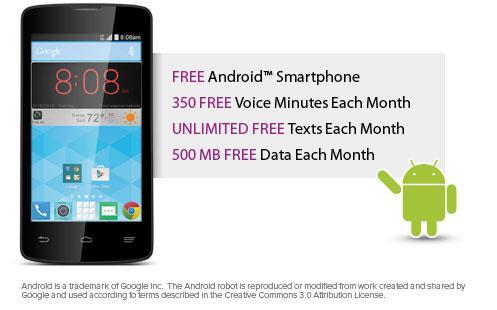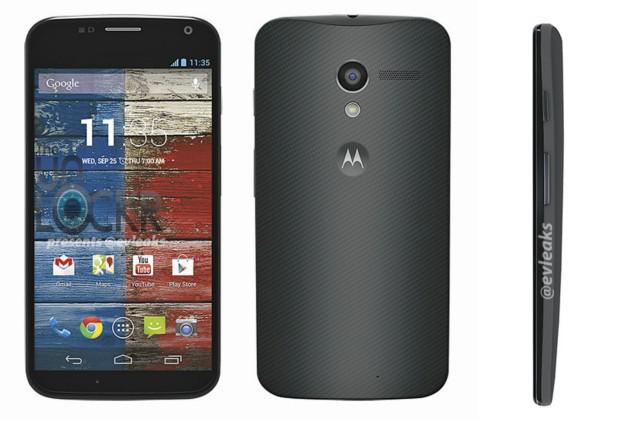The first image is the image on the left, the second image is the image on the right. For the images displayed, is the sentence "The back of a phone is completely visible." factually correct? Answer yes or no. Yes. The first image is the image on the left, the second image is the image on the right. Analyze the images presented: Is the assertion "There is  total of four phones with the right side having more." valid? Answer yes or no. Yes. 